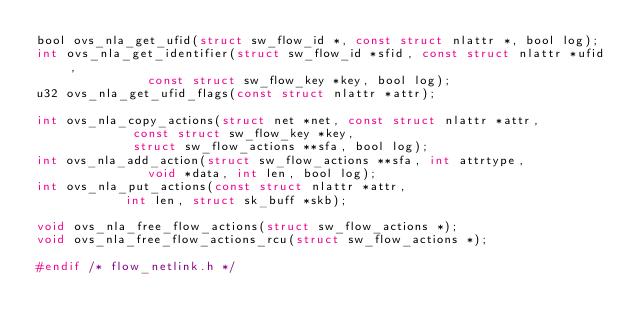<code> <loc_0><loc_0><loc_500><loc_500><_C_>bool ovs_nla_get_ufid(struct sw_flow_id *, const struct nlattr *, bool log);
int ovs_nla_get_identifier(struct sw_flow_id *sfid, const struct nlattr *ufid,
			   const struct sw_flow_key *key, bool log);
u32 ovs_nla_get_ufid_flags(const struct nlattr *attr);

int ovs_nla_copy_actions(struct net *net, const struct nlattr *attr,
			 const struct sw_flow_key *key,
			 struct sw_flow_actions **sfa, bool log);
int ovs_nla_add_action(struct sw_flow_actions **sfa, int attrtype,
		       void *data, int len, bool log);
int ovs_nla_put_actions(const struct nlattr *attr,
			int len, struct sk_buff *skb);

void ovs_nla_free_flow_actions(struct sw_flow_actions *);
void ovs_nla_free_flow_actions_rcu(struct sw_flow_actions *);

#endif /* flow_netlink.h */
</code> 